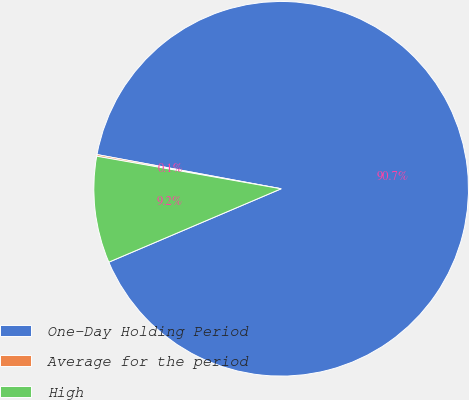Convert chart to OTSL. <chart><loc_0><loc_0><loc_500><loc_500><pie_chart><fcel>One-Day Holding Period<fcel>Average for the period<fcel>High<nl><fcel>90.67%<fcel>0.14%<fcel>9.19%<nl></chart> 